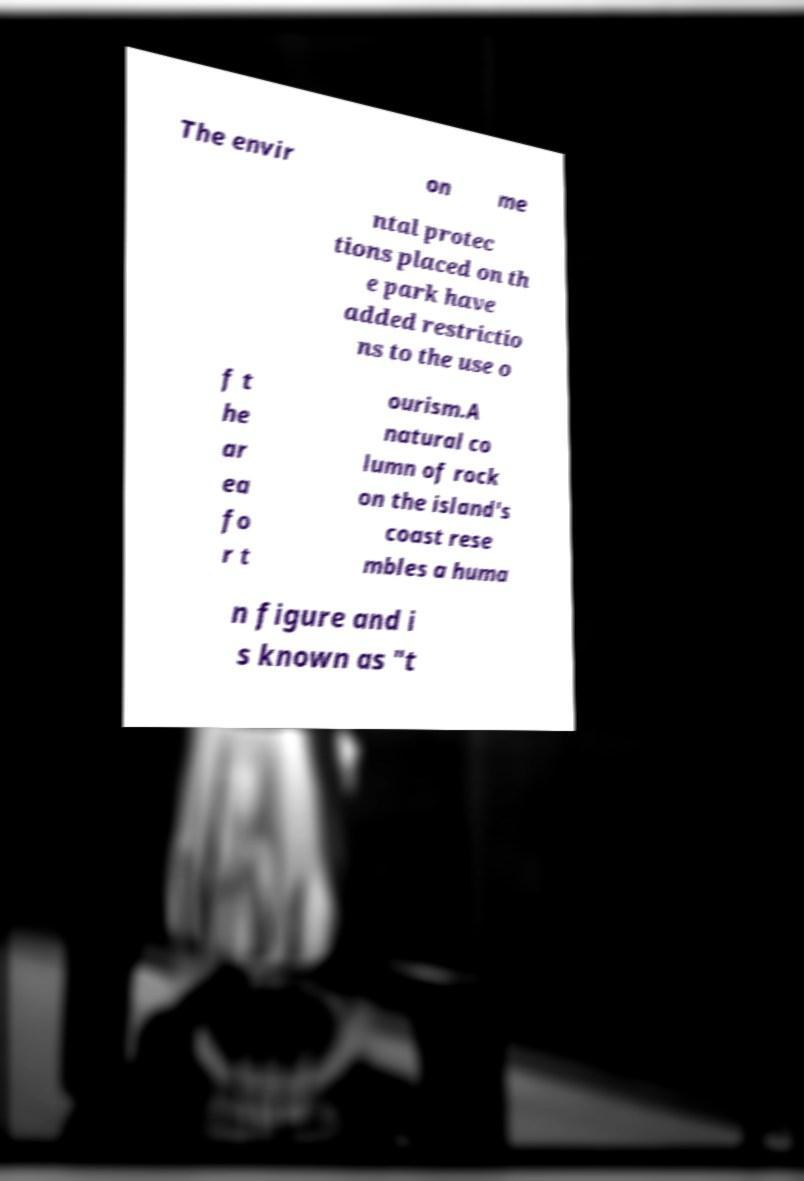Can you read and provide the text displayed in the image?This photo seems to have some interesting text. Can you extract and type it out for me? The envir on me ntal protec tions placed on th e park have added restrictio ns to the use o f t he ar ea fo r t ourism.A natural co lumn of rock on the island's coast rese mbles a huma n figure and i s known as "t 